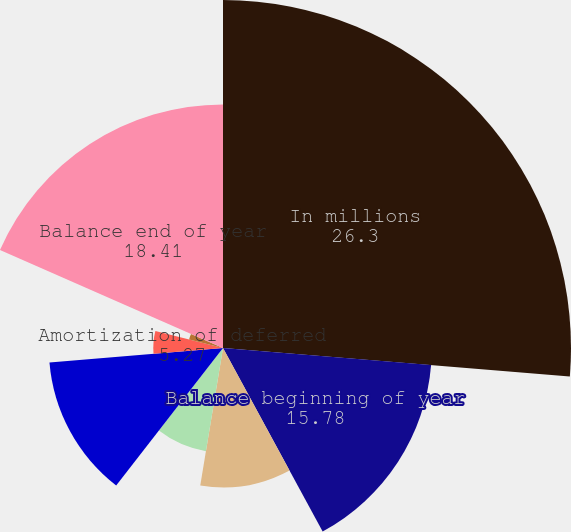Convert chart. <chart><loc_0><loc_0><loc_500><loc_500><pie_chart><fcel>In millions<fcel>Balance beginning of year<fcel>Provision for warranties<fcel>Deferred revenue on extended<fcel>Payments<fcel>Amortization of deferred<fcel>Changes in estimates for<fcel>Foreign currency translation<fcel>Balance end of year<nl><fcel>26.3%<fcel>15.78%<fcel>10.53%<fcel>7.9%<fcel>13.16%<fcel>5.27%<fcel>2.64%<fcel>0.01%<fcel>18.41%<nl></chart> 